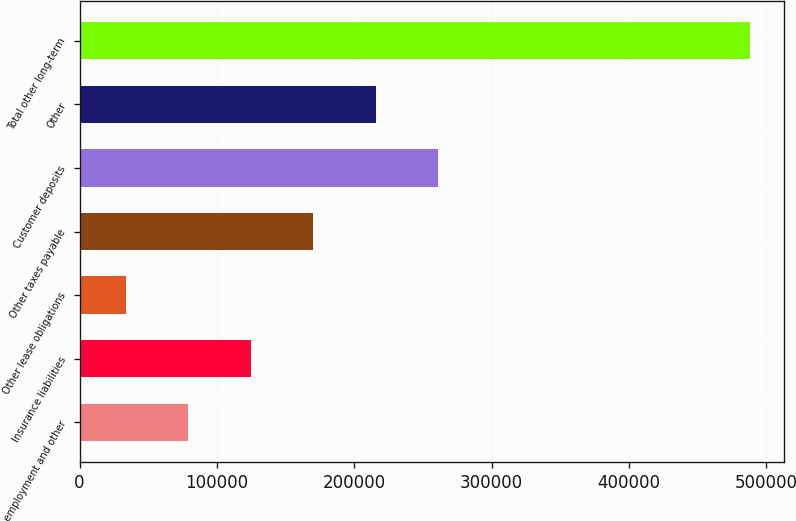<chart> <loc_0><loc_0><loc_500><loc_500><bar_chart><fcel>Post-employment and other<fcel>Insurance liabilities<fcel>Other lease obligations<fcel>Other taxes payable<fcel>Customer deposits<fcel>Other<fcel>Total other long-term<nl><fcel>79198.8<fcel>124650<fcel>33748<fcel>170100<fcel>261002<fcel>215551<fcel>488256<nl></chart> 